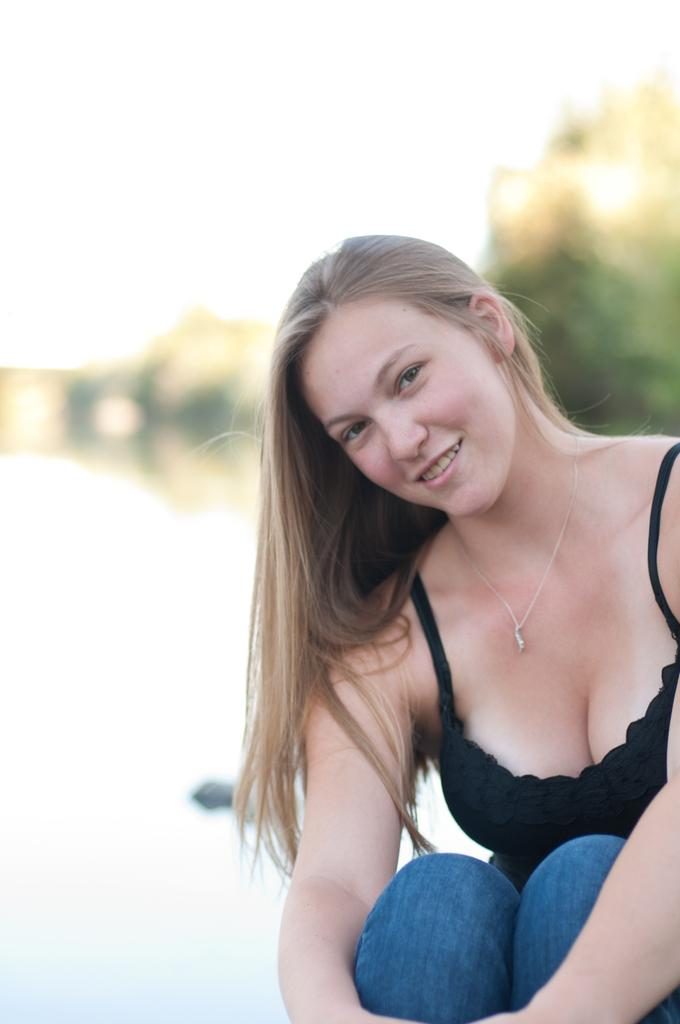What is the main subject of the image? The main subject of the image is a lady sitting on the right side of the image. Can you describe the background in the image? The background behind her is blurred. What type of wood is the beef being served on in the image? There is no wood or beef present in the image; it only features a lady sitting on the right side with a blurred background. 